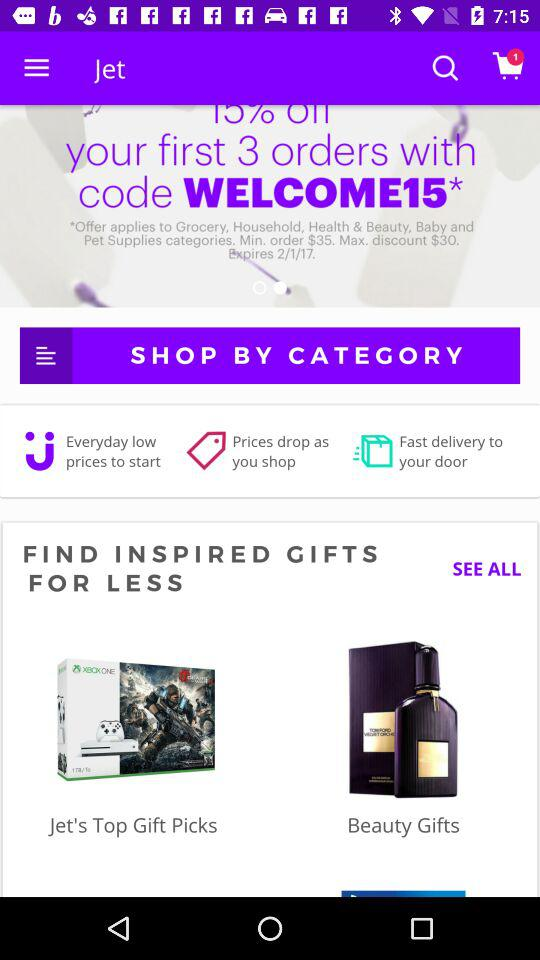How many items are in the cart? There is 1 item in the cart. 